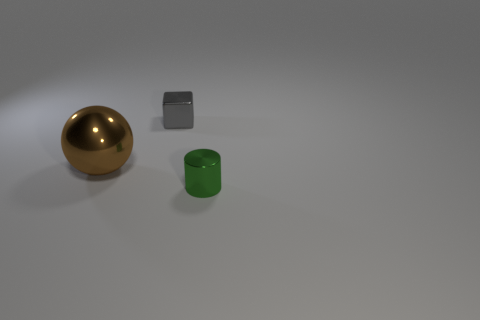There is a object that is to the left of the tiny shiny object behind the small thing to the right of the metal cube; what is its size?
Give a very brief answer. Large. There is a thing that is both to the right of the brown ball and in front of the gray thing; how big is it?
Make the answer very short. Small. Does the small object to the right of the tiny metallic block have the same color as the shiny sphere in front of the gray cube?
Your response must be concise. No. There is a small green metal thing; what number of cylinders are right of it?
Your response must be concise. 0. There is a tiny metallic thing that is to the left of the object in front of the large thing; is there a gray shiny cube on the left side of it?
Provide a short and direct response. No. What number of objects have the same size as the cylinder?
Keep it short and to the point. 1. There is a small thing in front of the small metal object on the left side of the small green shiny thing; what is it made of?
Provide a short and direct response. Metal. What is the shape of the small shiny object that is in front of the small metallic thing that is left of the tiny object in front of the gray object?
Provide a succinct answer. Cylinder. Does the tiny thing that is left of the shiny cylinder have the same shape as the object left of the block?
Your answer should be compact. No. What number of other things are the same material as the large object?
Provide a short and direct response. 2. 